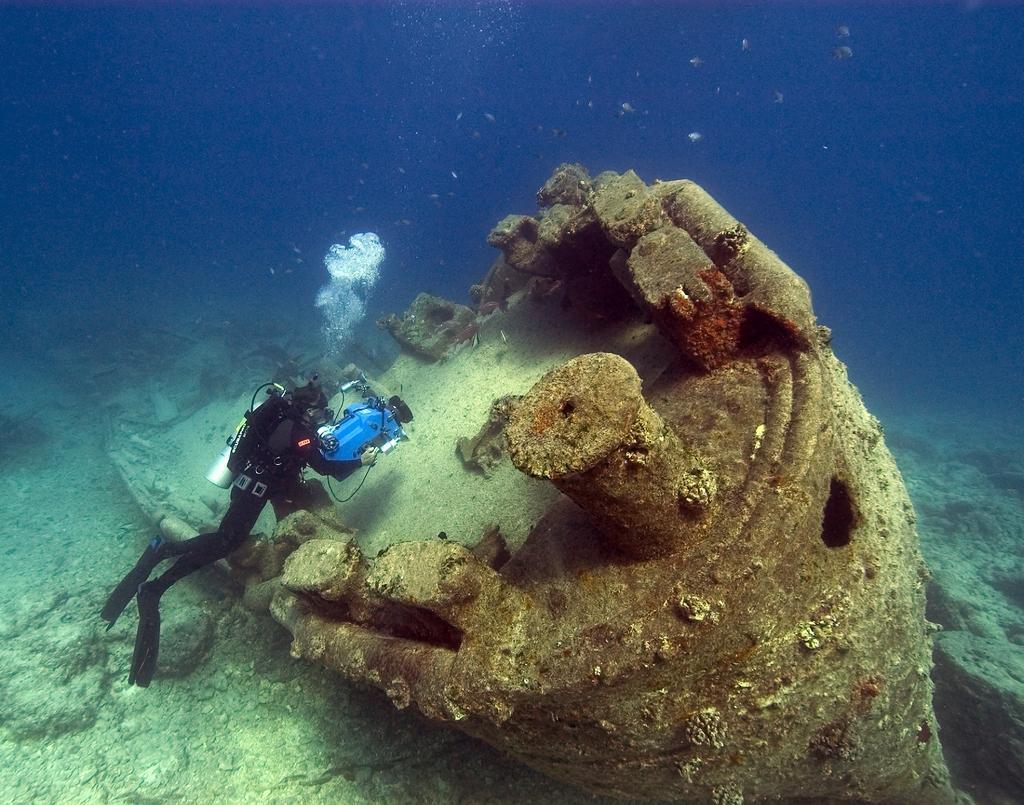Describe this image in one or two sentences. In this image, we can see under the water view. Here a person is divine and holding some machine. Here we can see a piece of the boat in the water. 